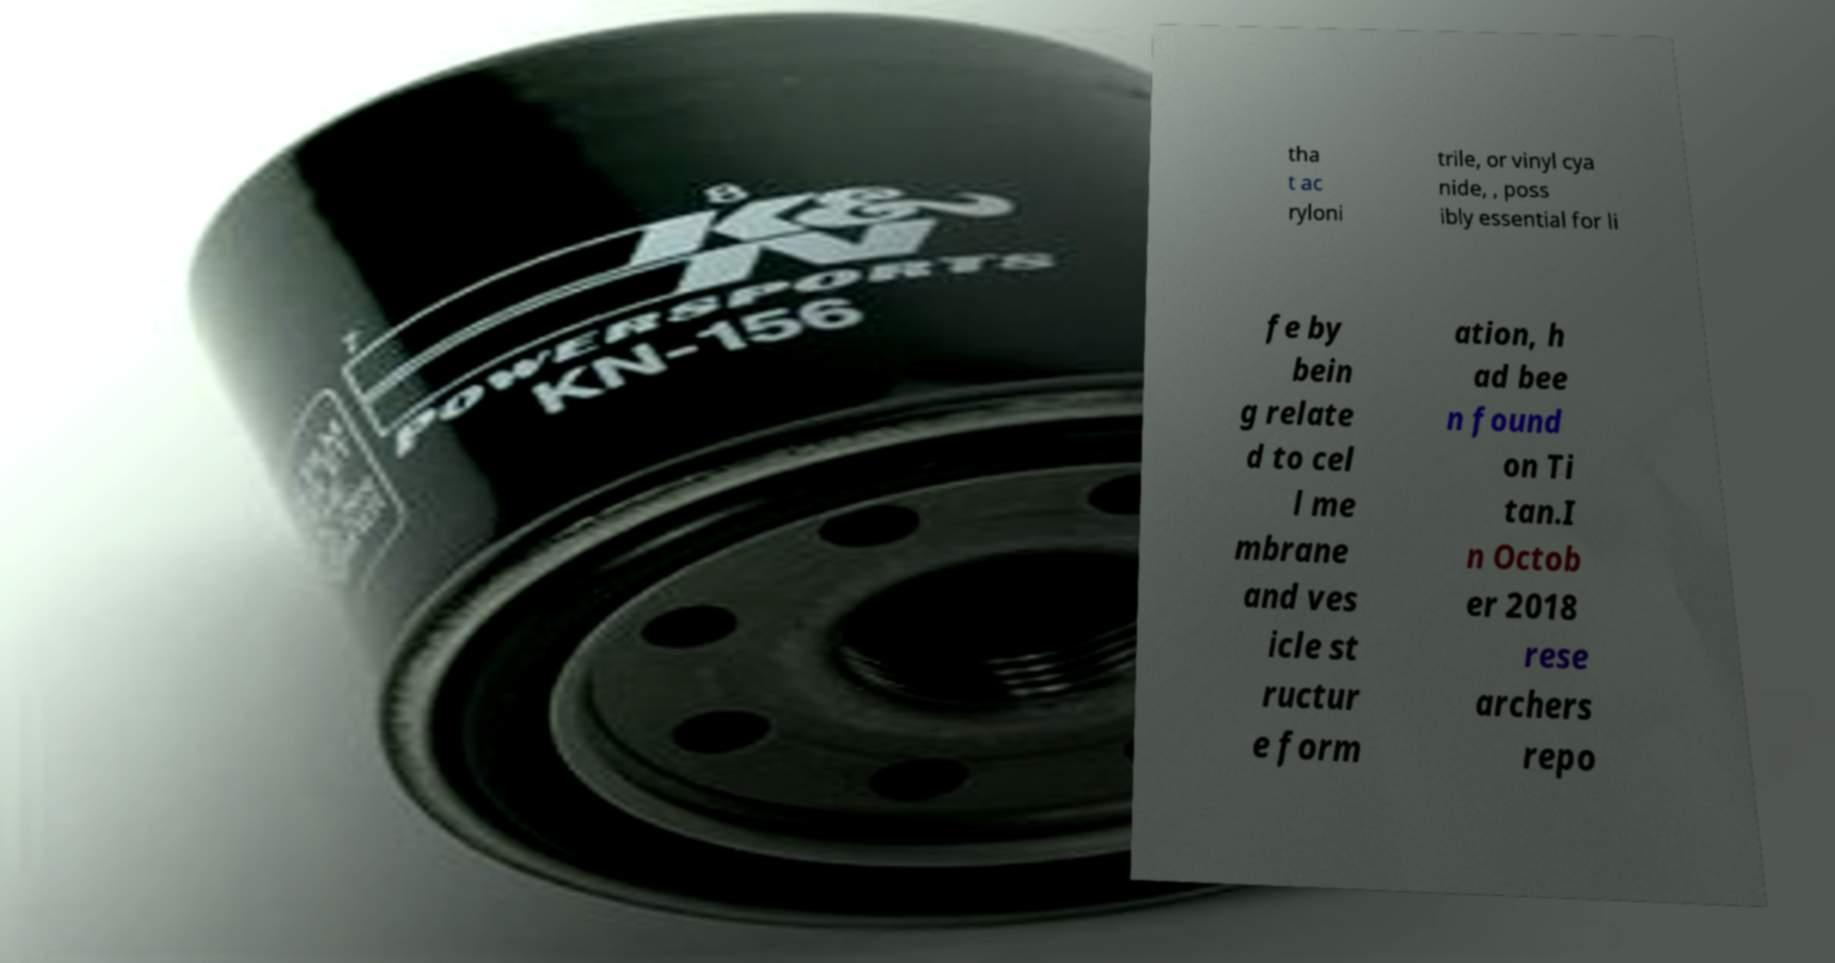Can you accurately transcribe the text from the provided image for me? tha t ac ryloni trile, or vinyl cya nide, , poss ibly essential for li fe by bein g relate d to cel l me mbrane and ves icle st ructur e form ation, h ad bee n found on Ti tan.I n Octob er 2018 rese archers repo 